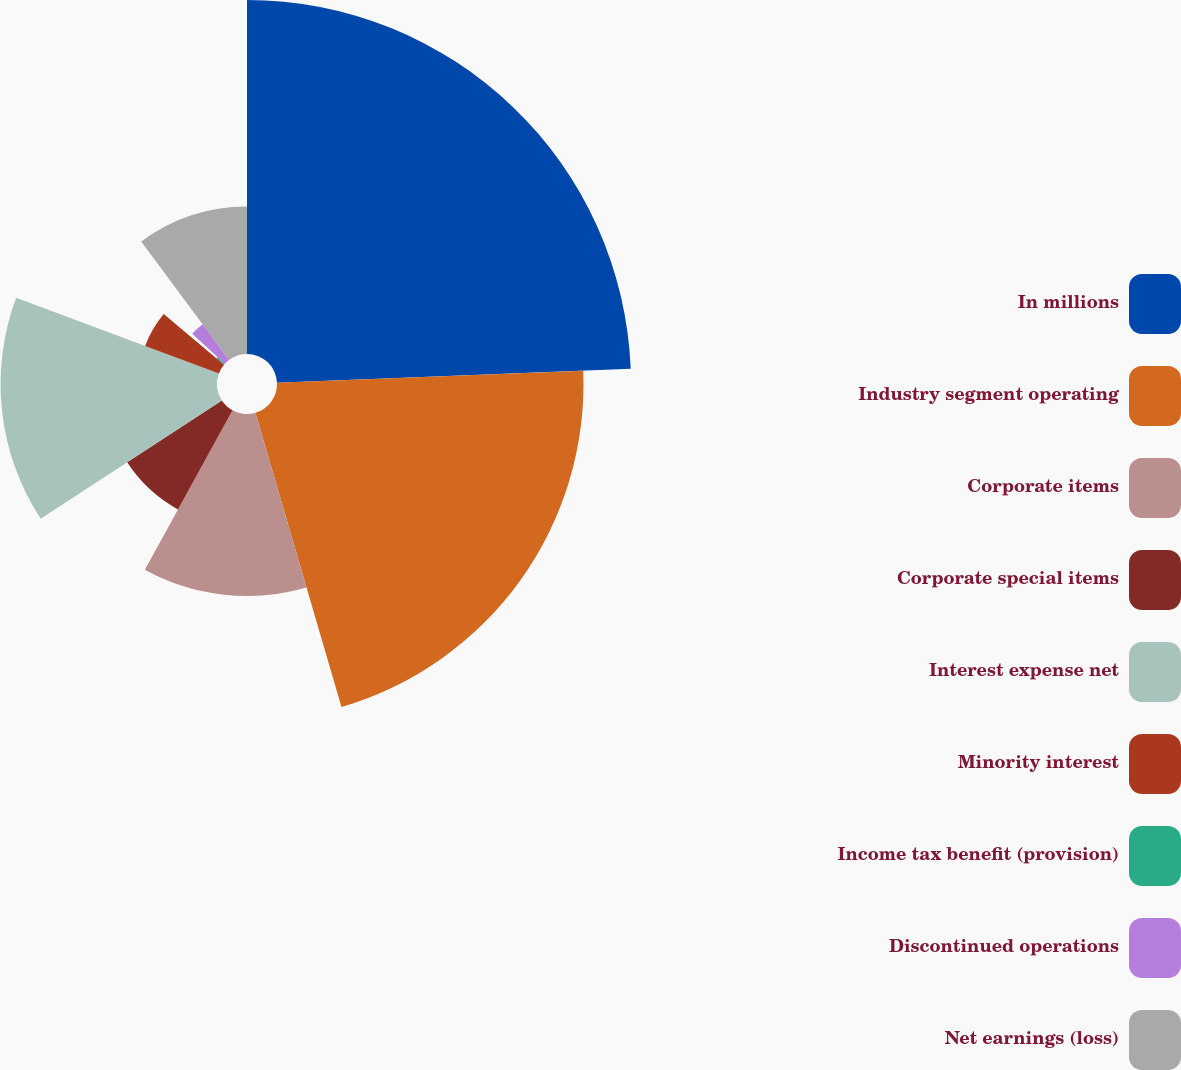Convert chart to OTSL. <chart><loc_0><loc_0><loc_500><loc_500><pie_chart><fcel>In millions<fcel>Industry segment operating<fcel>Corporate items<fcel>Corporate special items<fcel>Interest expense net<fcel>Minority interest<fcel>Income tax benefit (provision)<fcel>Discontinued operations<fcel>Net earnings (loss)<nl><fcel>24.37%<fcel>21.1%<fcel>12.53%<fcel>7.79%<fcel>14.9%<fcel>5.42%<fcel>0.68%<fcel>3.05%<fcel>10.16%<nl></chart> 